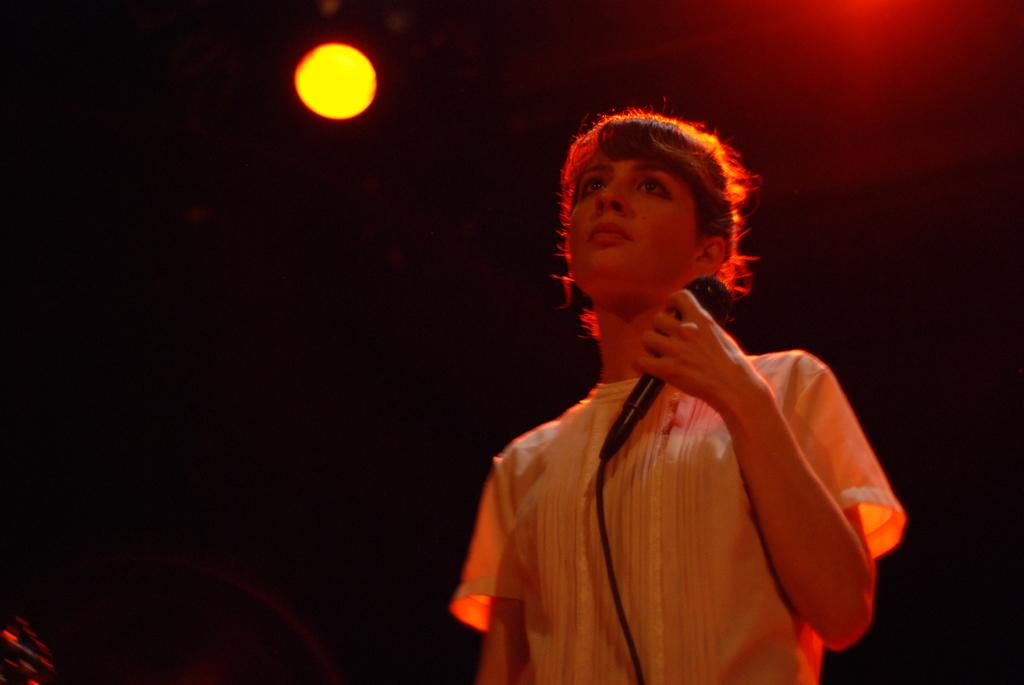What is the main subject of the image? There is a person in the image. What is the person holding in the image? The person is holding a microphone. Can you describe the lighting in the image? There is light visible in the image. What type of wren can be seen making a decision in the store in the image? There is no wren or store present in the image; it features a person holding a microphone. 